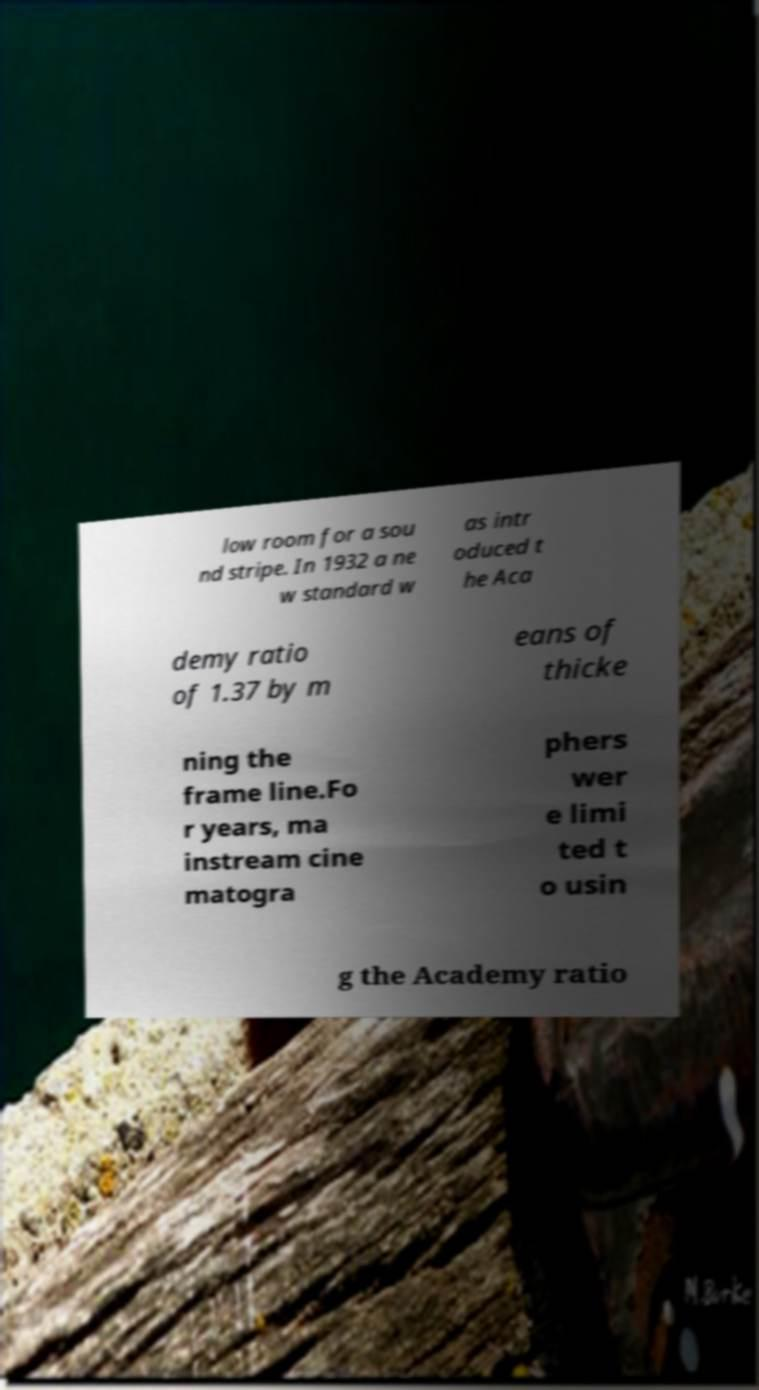Can you accurately transcribe the text from the provided image for me? low room for a sou nd stripe. In 1932 a ne w standard w as intr oduced t he Aca demy ratio of 1.37 by m eans of thicke ning the frame line.Fo r years, ma instream cine matogra phers wer e limi ted t o usin g the Academy ratio 